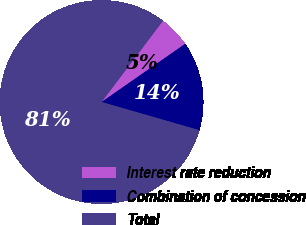<chart> <loc_0><loc_0><loc_500><loc_500><pie_chart><fcel>Interest rate reduction<fcel>Combination of concession<fcel>Total<nl><fcel>5.02%<fcel>14.14%<fcel>80.85%<nl></chart> 